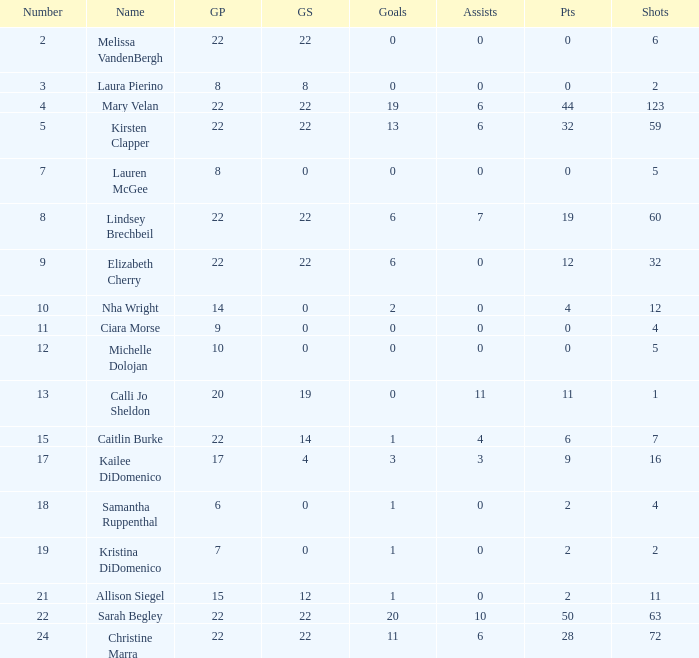How many numbers belong to the player with 10 assists?  1.0. 